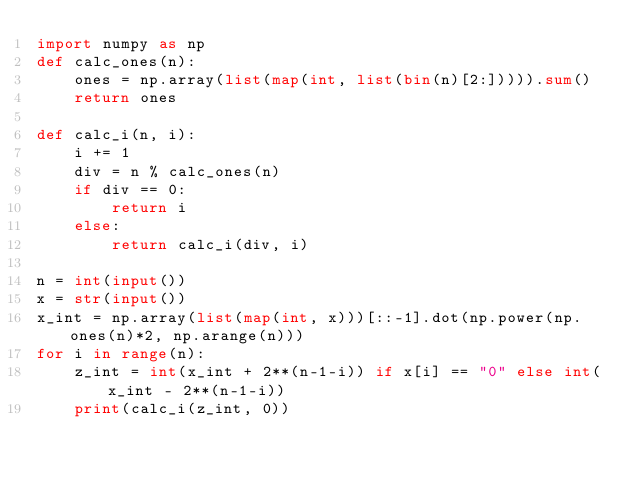Convert code to text. <code><loc_0><loc_0><loc_500><loc_500><_Python_>import numpy as np
def calc_ones(n):
    ones = np.array(list(map(int, list(bin(n)[2:])))).sum()
    return ones

def calc_i(n, i):
    i += 1
    div = n % calc_ones(n)
    if div == 0:
        return i
    else:
        return calc_i(div, i)

n = int(input())
x = str(input())
x_int = np.array(list(map(int, x)))[::-1].dot(np.power(np.ones(n)*2, np.arange(n)))
for i in range(n):
    z_int = int(x_int + 2**(n-1-i)) if x[i] == "0" else int(x_int - 2**(n-1-i))
    print(calc_i(z_int, 0))</code> 